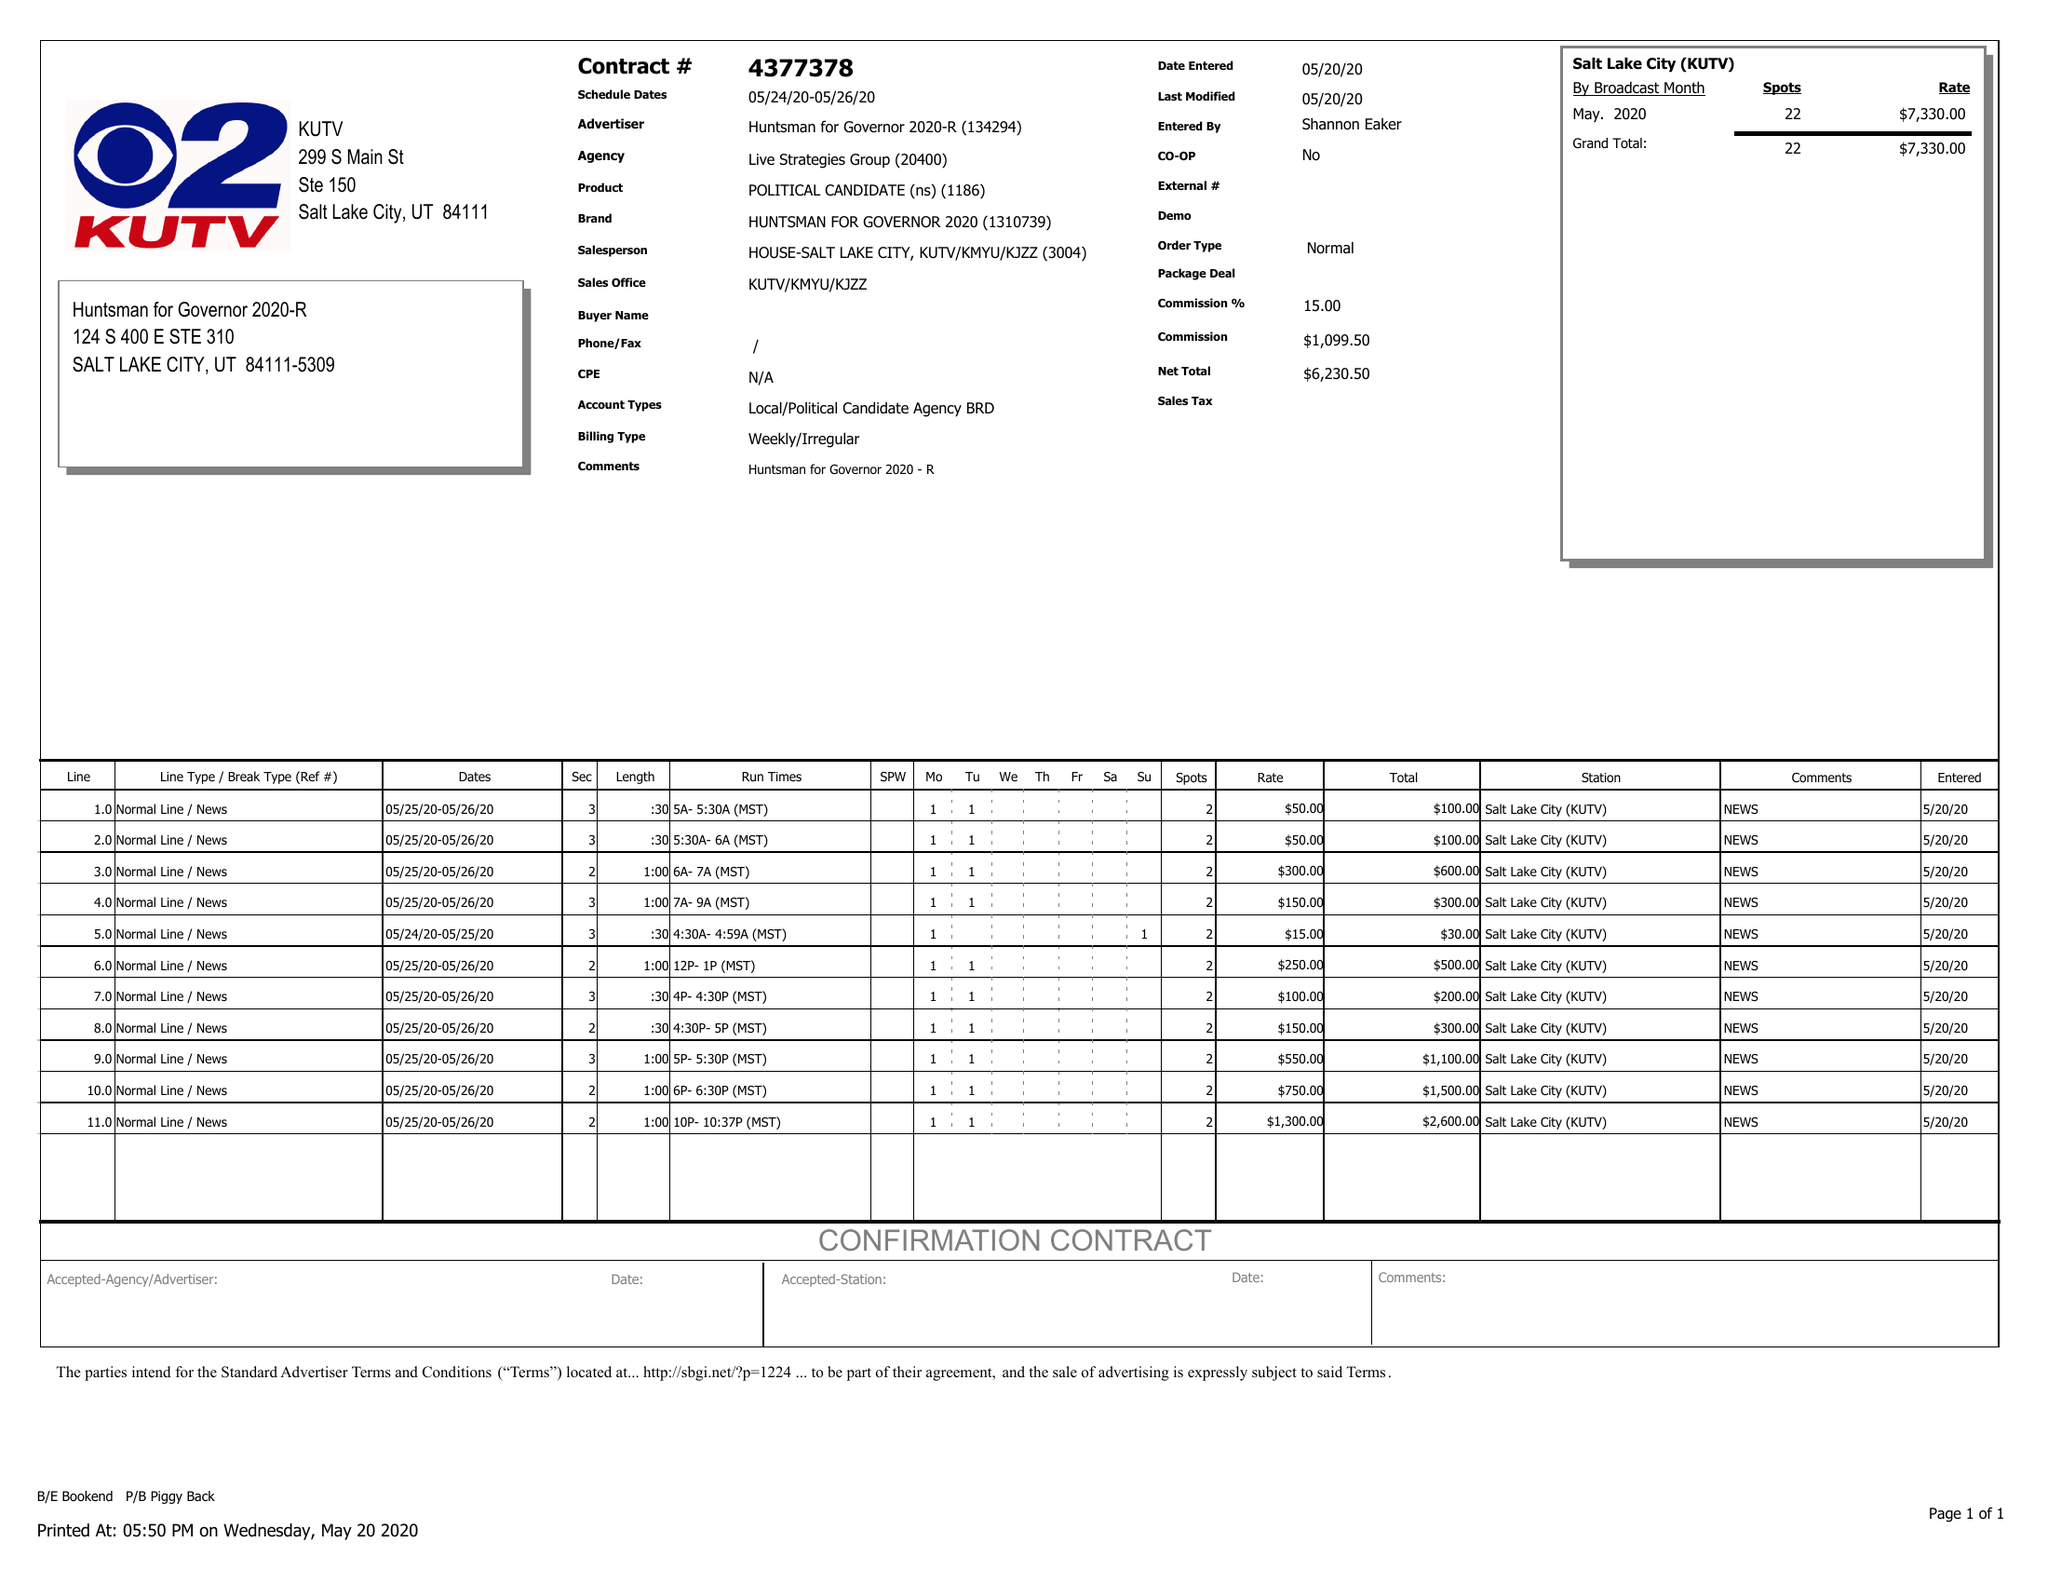What is the value for the gross_amount?
Answer the question using a single word or phrase. 7330.00 